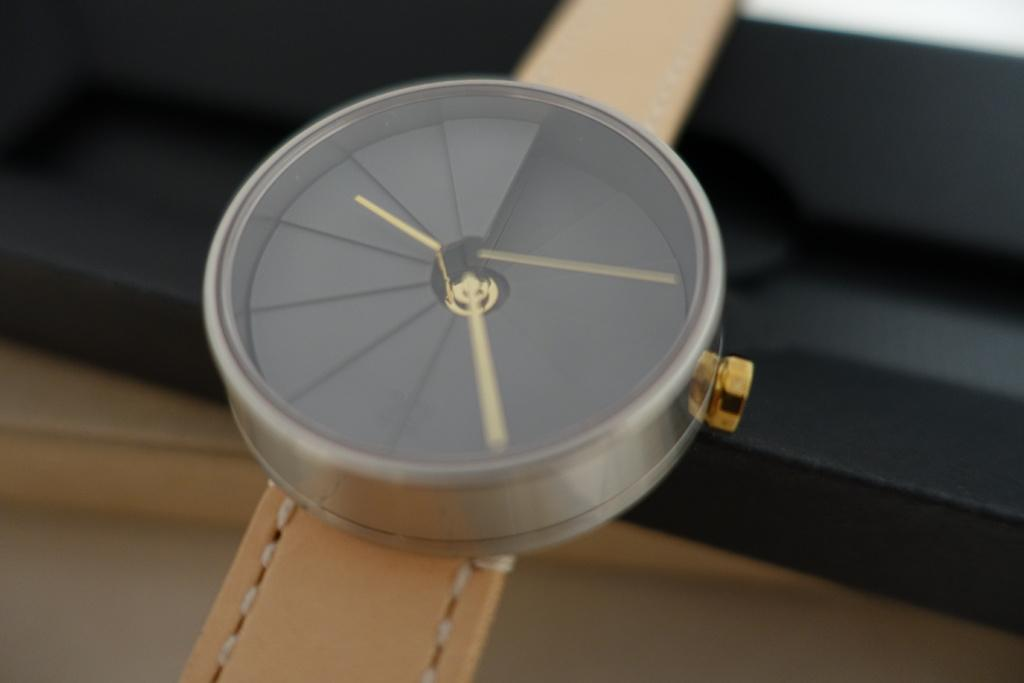What object is the main focus of the image? There is a watch in the image. Can you describe the background of the image? The background of the image is black and brown in color. How many cows are visible in the image? There are no cows present in the image; it features a watch and a black and brown background. What type of discovery is being made in the image? There is no discovery being made in the image; it simply shows a watch against a black and brown background. 